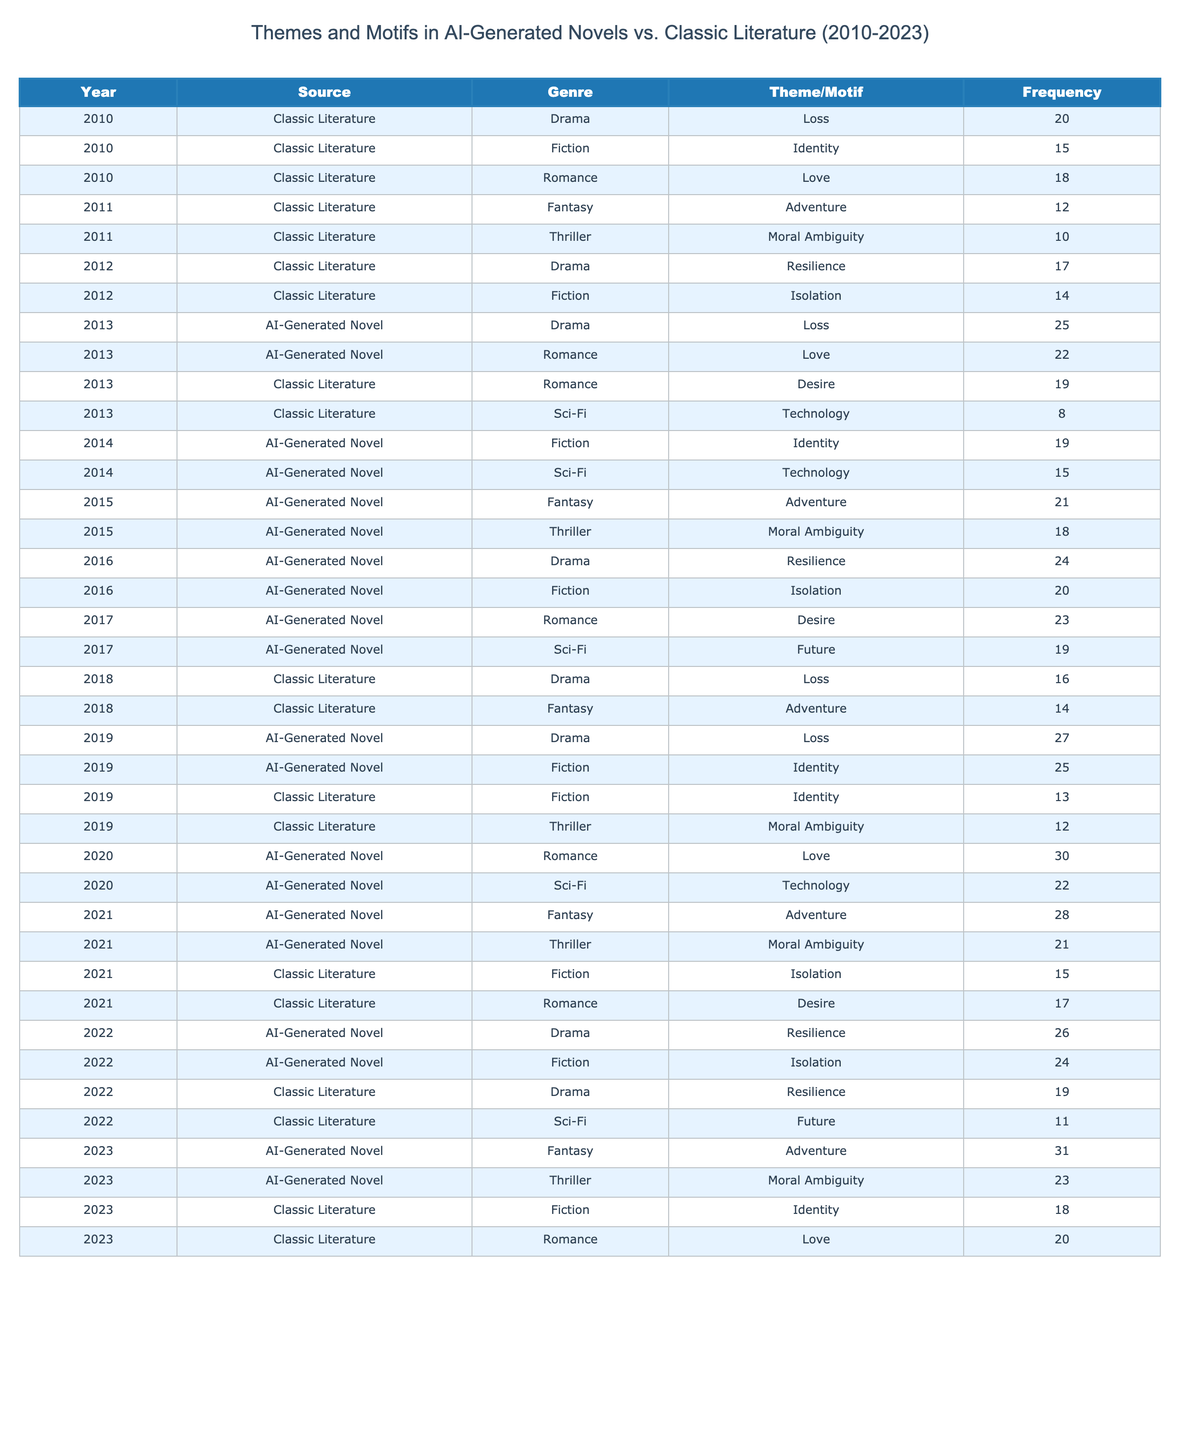What is the theme with the highest frequency in AI-generated novels in 2023? According to the table, the theme with the highest frequency in AI-generated novels for 2023 is "Adventure," with a frequency of 31.
Answer: Adventure How many AI-generated novels feature the theme "Identity" in total from 2013 to 2023? In the years from 2013 to 2023, the frequencies for "Identity" are 25 (2019) and 19 (2014). Adding these gives a total of 44.
Answer: 44 What is the frequency of the theme "Love" in classic literature for the year 2023? In 2023, the frequency of the theme "Love" in classic literature is 20.
Answer: 20 Did AI-generated novels feature the theme "Technology" in more years compared to classic literature from 2010 to 2023? Yes, AI-generated novels featured "Technology" in the years 2013, 2014, 2020, and in total 4 different years, while classic literature featured it in 2013 and 2022, totaling 2 different years.
Answer: Yes Which genre has the highest total frequency for the theme "Loss" across both AI-generated novels and classic literature from 2010 to 2023? To find the total frequency of "Loss," we look at the values: Classic Literature (20 in 2010, 16 in 2018) gives 36, while AI-generated (25 in 2013, 27 in 2019) gives 52. So the total for AI-generated is higher.
Answer: AI-generated novels What is the overall trend for the theme "Adventure" in AI-generated novels from 2013 to 2023? The frequency values for "Adventure" in AI-generated novels are 25 (2013), 21 (2015), 28 (2021), and 31 (2023). The trend is upward as it increases each year.
Answer: Upward What is the average frequency of the theme "Desire" in AI-generated novels? Moving through the years, the values for "Desire" in AI-generated novels are 22 (2013), 23 (2017), and 17 (2021). We sum these (22 + 23 + 17 = 62) and divide by the number of entries (3) yielding an average of 20.67.
Answer: 20.67 How does the frequency of the theme "Moral Ambiguity" in AI-generated novels compare to that in classic literature for 2021? The frequency for "Moral Ambiguity" in AI-generated novels for 2021 is 21, while in classic literature it is 12 for 2019. Comparatively, AI-generated novels have a higher frequency.
Answer: AI-generated novels have higher frequency What percentage of the total frequency of "Loss" in both genres is attributed to AI-generated novels from 2010 to 2023? The frequencies for "Loss": Classic Literature (20 + 16 = 36) and AI-generated novels (25 + 27 = 52). Total frequency is 88. AI-generated novels have 52/88, which is 59.09%.
Answer: 59.09% What is the most frequently occurring theme in thriller genre novels across both AI-generated and classic literature? The highest frequency for "Moral Ambiguity" is 21 in AI-generated novels for 2021, while classic literature has 12 in 2019. The most frequently occurring theme in thrillers is "Moral Ambiguity" from AI-generated novels.
Answer: Moral Ambiguity 